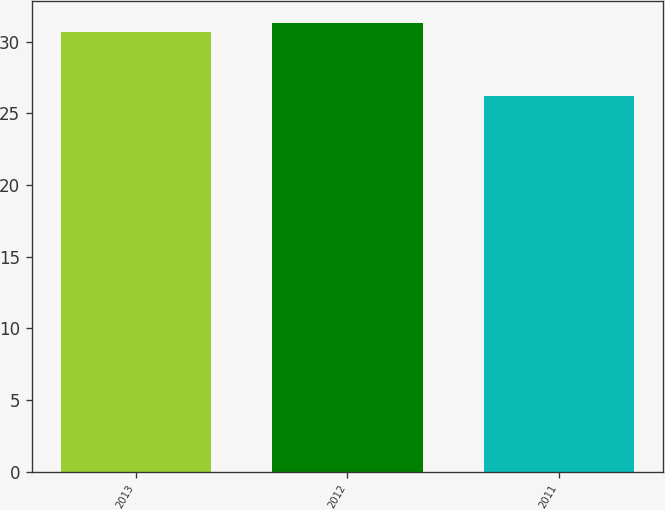Convert chart to OTSL. <chart><loc_0><loc_0><loc_500><loc_500><bar_chart><fcel>2013<fcel>2012<fcel>2011<nl><fcel>30.7<fcel>31.3<fcel>26.2<nl></chart> 